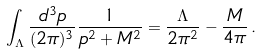Convert formula to latex. <formula><loc_0><loc_0><loc_500><loc_500>\int _ { \Lambda } \frac { d ^ { 3 } p } { ( 2 \pi ) ^ { 3 } } \frac { 1 } { p ^ { 2 } + M ^ { 2 } } = \frac { \Lambda } { 2 \pi ^ { 2 } } - \frac { M } { 4 \pi } \, .</formula> 